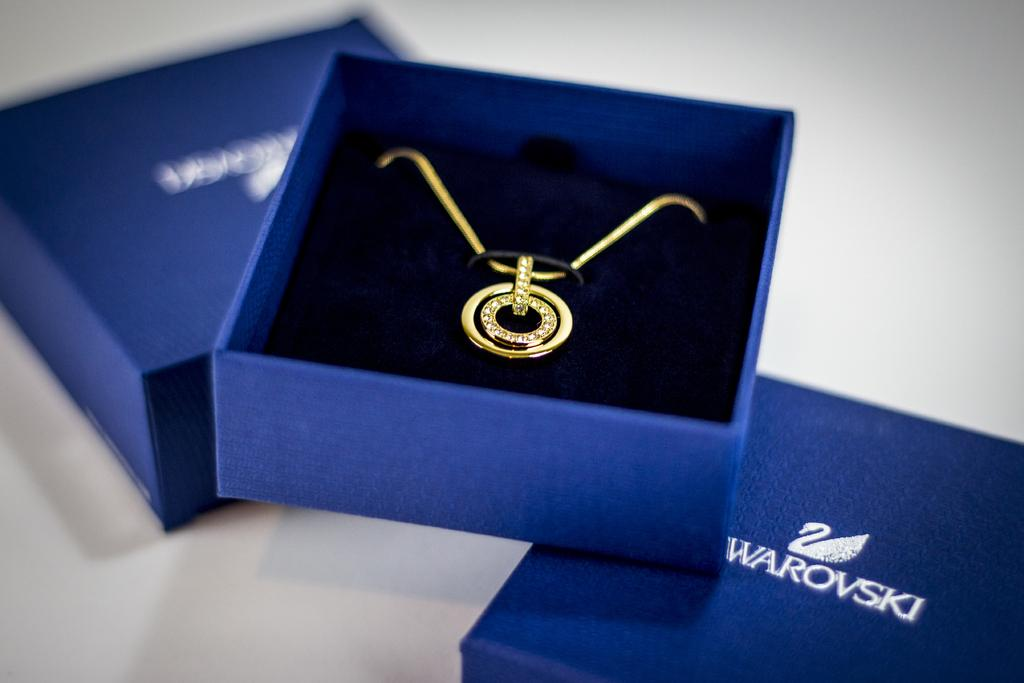Provide a one-sentence caption for the provided image. a Swarovski gold and diamond necklace in a blue box. 